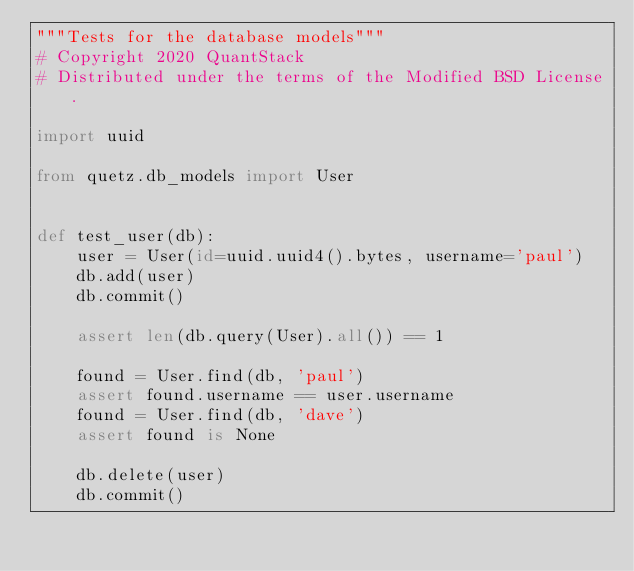Convert code to text. <code><loc_0><loc_0><loc_500><loc_500><_Python_>"""Tests for the database models"""
# Copyright 2020 QuantStack
# Distributed under the terms of the Modified BSD License.

import uuid

from quetz.db_models import User


def test_user(db):
    user = User(id=uuid.uuid4().bytes, username='paul')
    db.add(user)
    db.commit()

    assert len(db.query(User).all()) == 1

    found = User.find(db, 'paul')
    assert found.username == user.username
    found = User.find(db, 'dave')
    assert found is None

    db.delete(user)
    db.commit()
</code> 